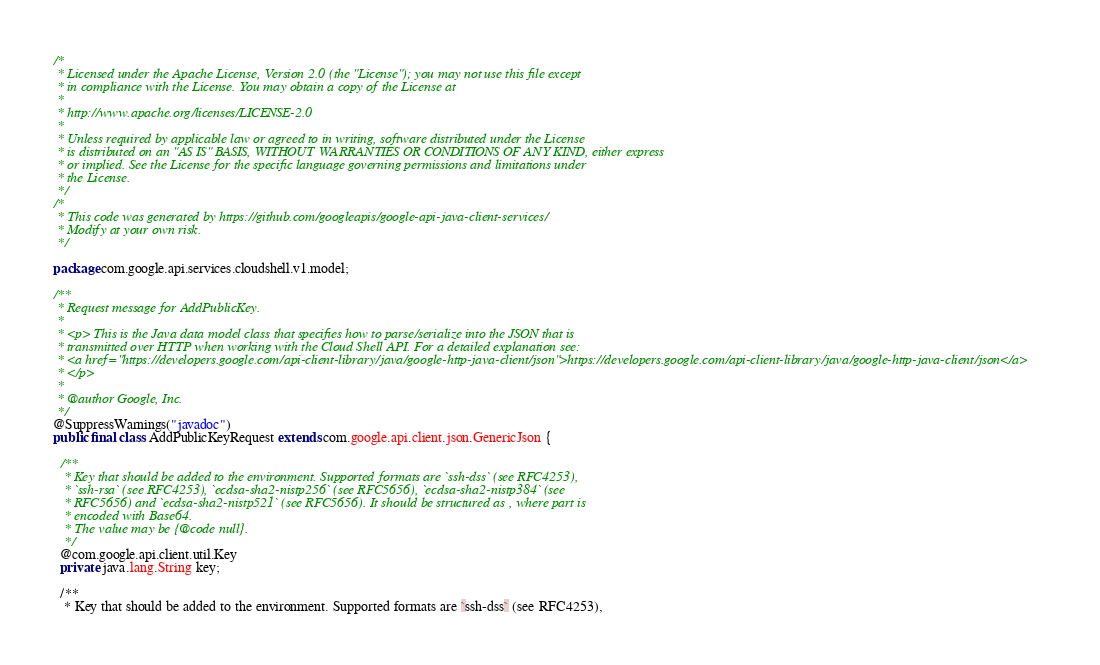<code> <loc_0><loc_0><loc_500><loc_500><_Java_>/*
 * Licensed under the Apache License, Version 2.0 (the "License"); you may not use this file except
 * in compliance with the License. You may obtain a copy of the License at
 *
 * http://www.apache.org/licenses/LICENSE-2.0
 *
 * Unless required by applicable law or agreed to in writing, software distributed under the License
 * is distributed on an "AS IS" BASIS, WITHOUT WARRANTIES OR CONDITIONS OF ANY KIND, either express
 * or implied. See the License for the specific language governing permissions and limitations under
 * the License.
 */
/*
 * This code was generated by https://github.com/googleapis/google-api-java-client-services/
 * Modify at your own risk.
 */

package com.google.api.services.cloudshell.v1.model;

/**
 * Request message for AddPublicKey.
 *
 * <p> This is the Java data model class that specifies how to parse/serialize into the JSON that is
 * transmitted over HTTP when working with the Cloud Shell API. For a detailed explanation see:
 * <a href="https://developers.google.com/api-client-library/java/google-http-java-client/json">https://developers.google.com/api-client-library/java/google-http-java-client/json</a>
 * </p>
 *
 * @author Google, Inc.
 */
@SuppressWarnings("javadoc")
public final class AddPublicKeyRequest extends com.google.api.client.json.GenericJson {

  /**
   * Key that should be added to the environment. Supported formats are `ssh-dss` (see RFC4253),
   * `ssh-rsa` (see RFC4253), `ecdsa-sha2-nistp256` (see RFC5656), `ecdsa-sha2-nistp384` (see
   * RFC5656) and `ecdsa-sha2-nistp521` (see RFC5656). It should be structured as , where part is
   * encoded with Base64.
   * The value may be {@code null}.
   */
  @com.google.api.client.util.Key
  private java.lang.String key;

  /**
   * Key that should be added to the environment. Supported formats are `ssh-dss` (see RFC4253),</code> 